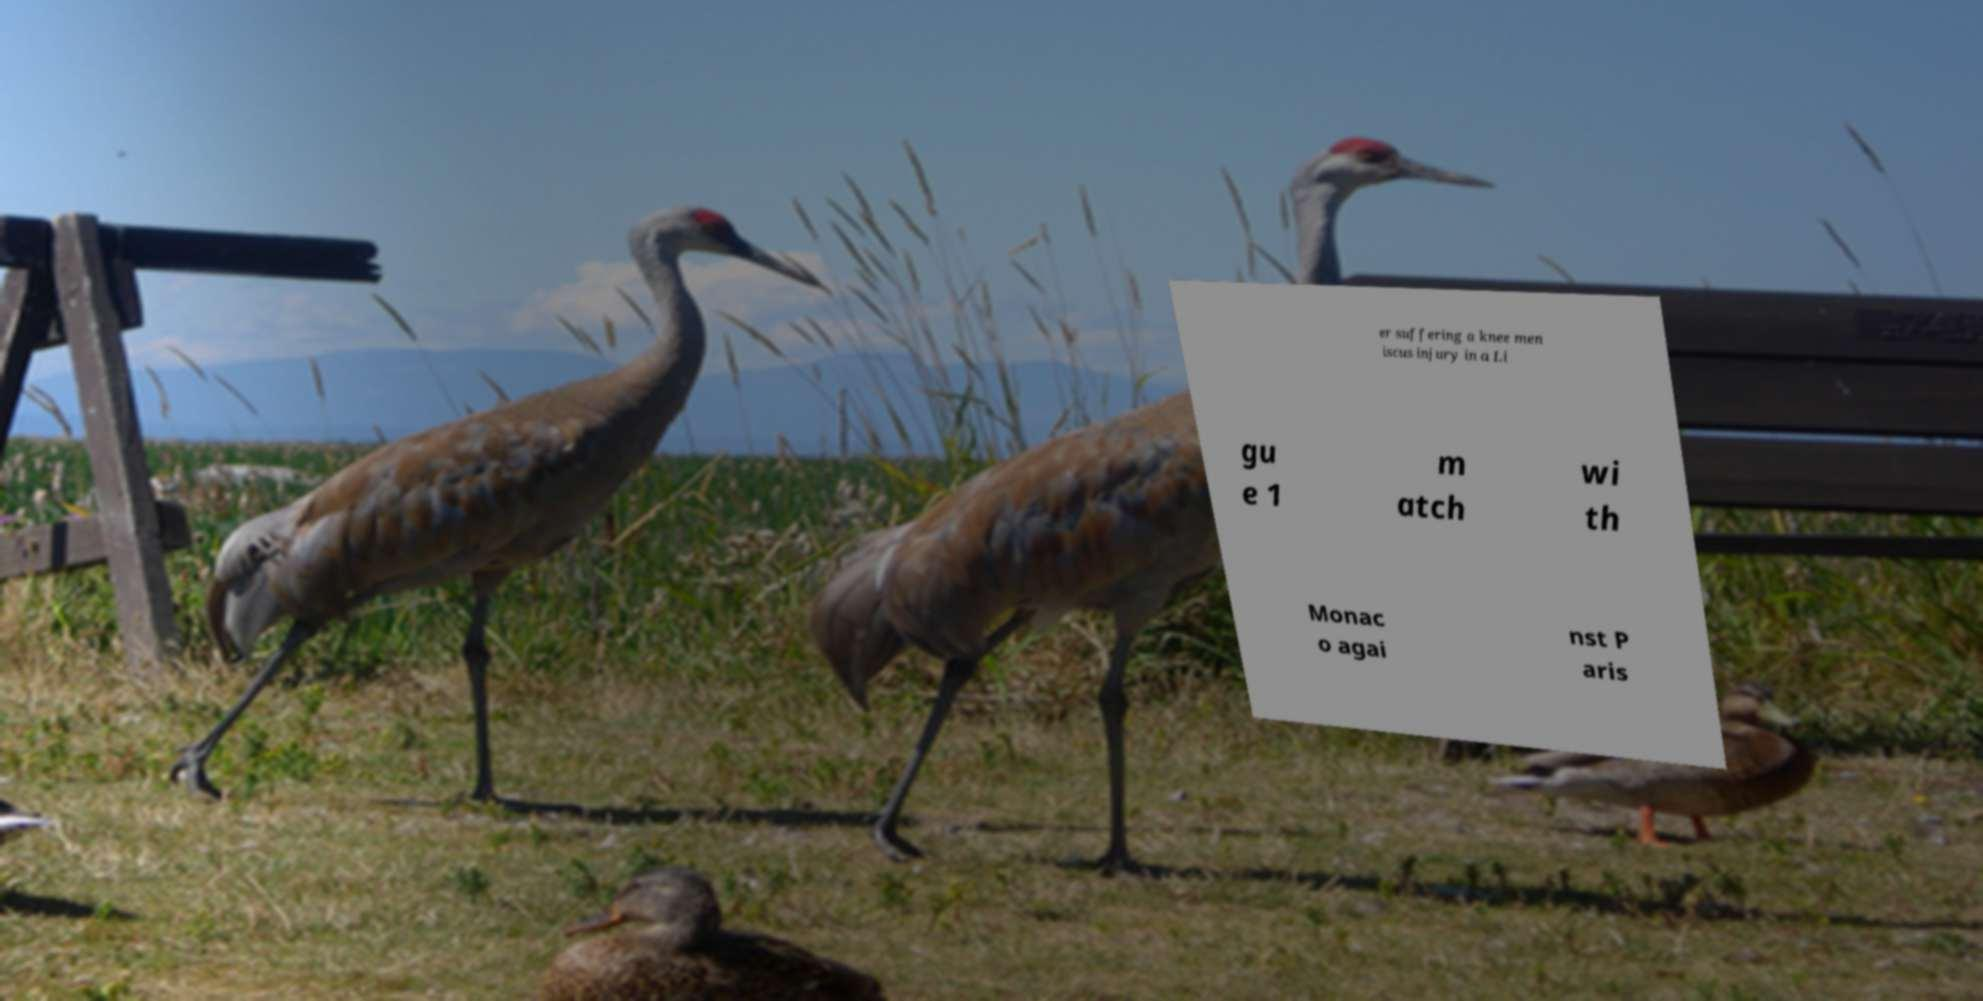What messages or text are displayed in this image? I need them in a readable, typed format. er suffering a knee men iscus injury in a Li gu e 1 m atch wi th Monac o agai nst P aris 